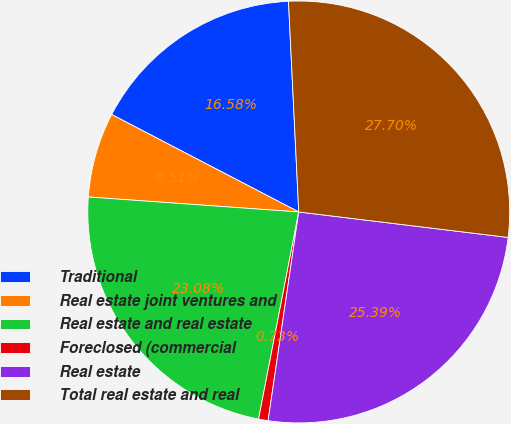Convert chart. <chart><loc_0><loc_0><loc_500><loc_500><pie_chart><fcel>Traditional<fcel>Real estate joint ventures and<fcel>Real estate and real estate<fcel>Foreclosed (commercial<fcel>Real estate<fcel>Total real estate and real<nl><fcel>16.58%<fcel>6.51%<fcel>23.08%<fcel>0.73%<fcel>25.39%<fcel>27.7%<nl></chart> 